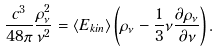Convert formula to latex. <formula><loc_0><loc_0><loc_500><loc_500>\frac { c ^ { 3 } } { 4 8 \pi } \frac { \rho _ { \nu } ^ { 2 } } { \nu ^ { 2 } } = \langle E _ { k i n } \rangle \left ( \rho _ { \nu } - \frac { 1 } { 3 } \nu \frac { \partial \rho _ { \nu } } { \partial \nu } \right ) .</formula> 